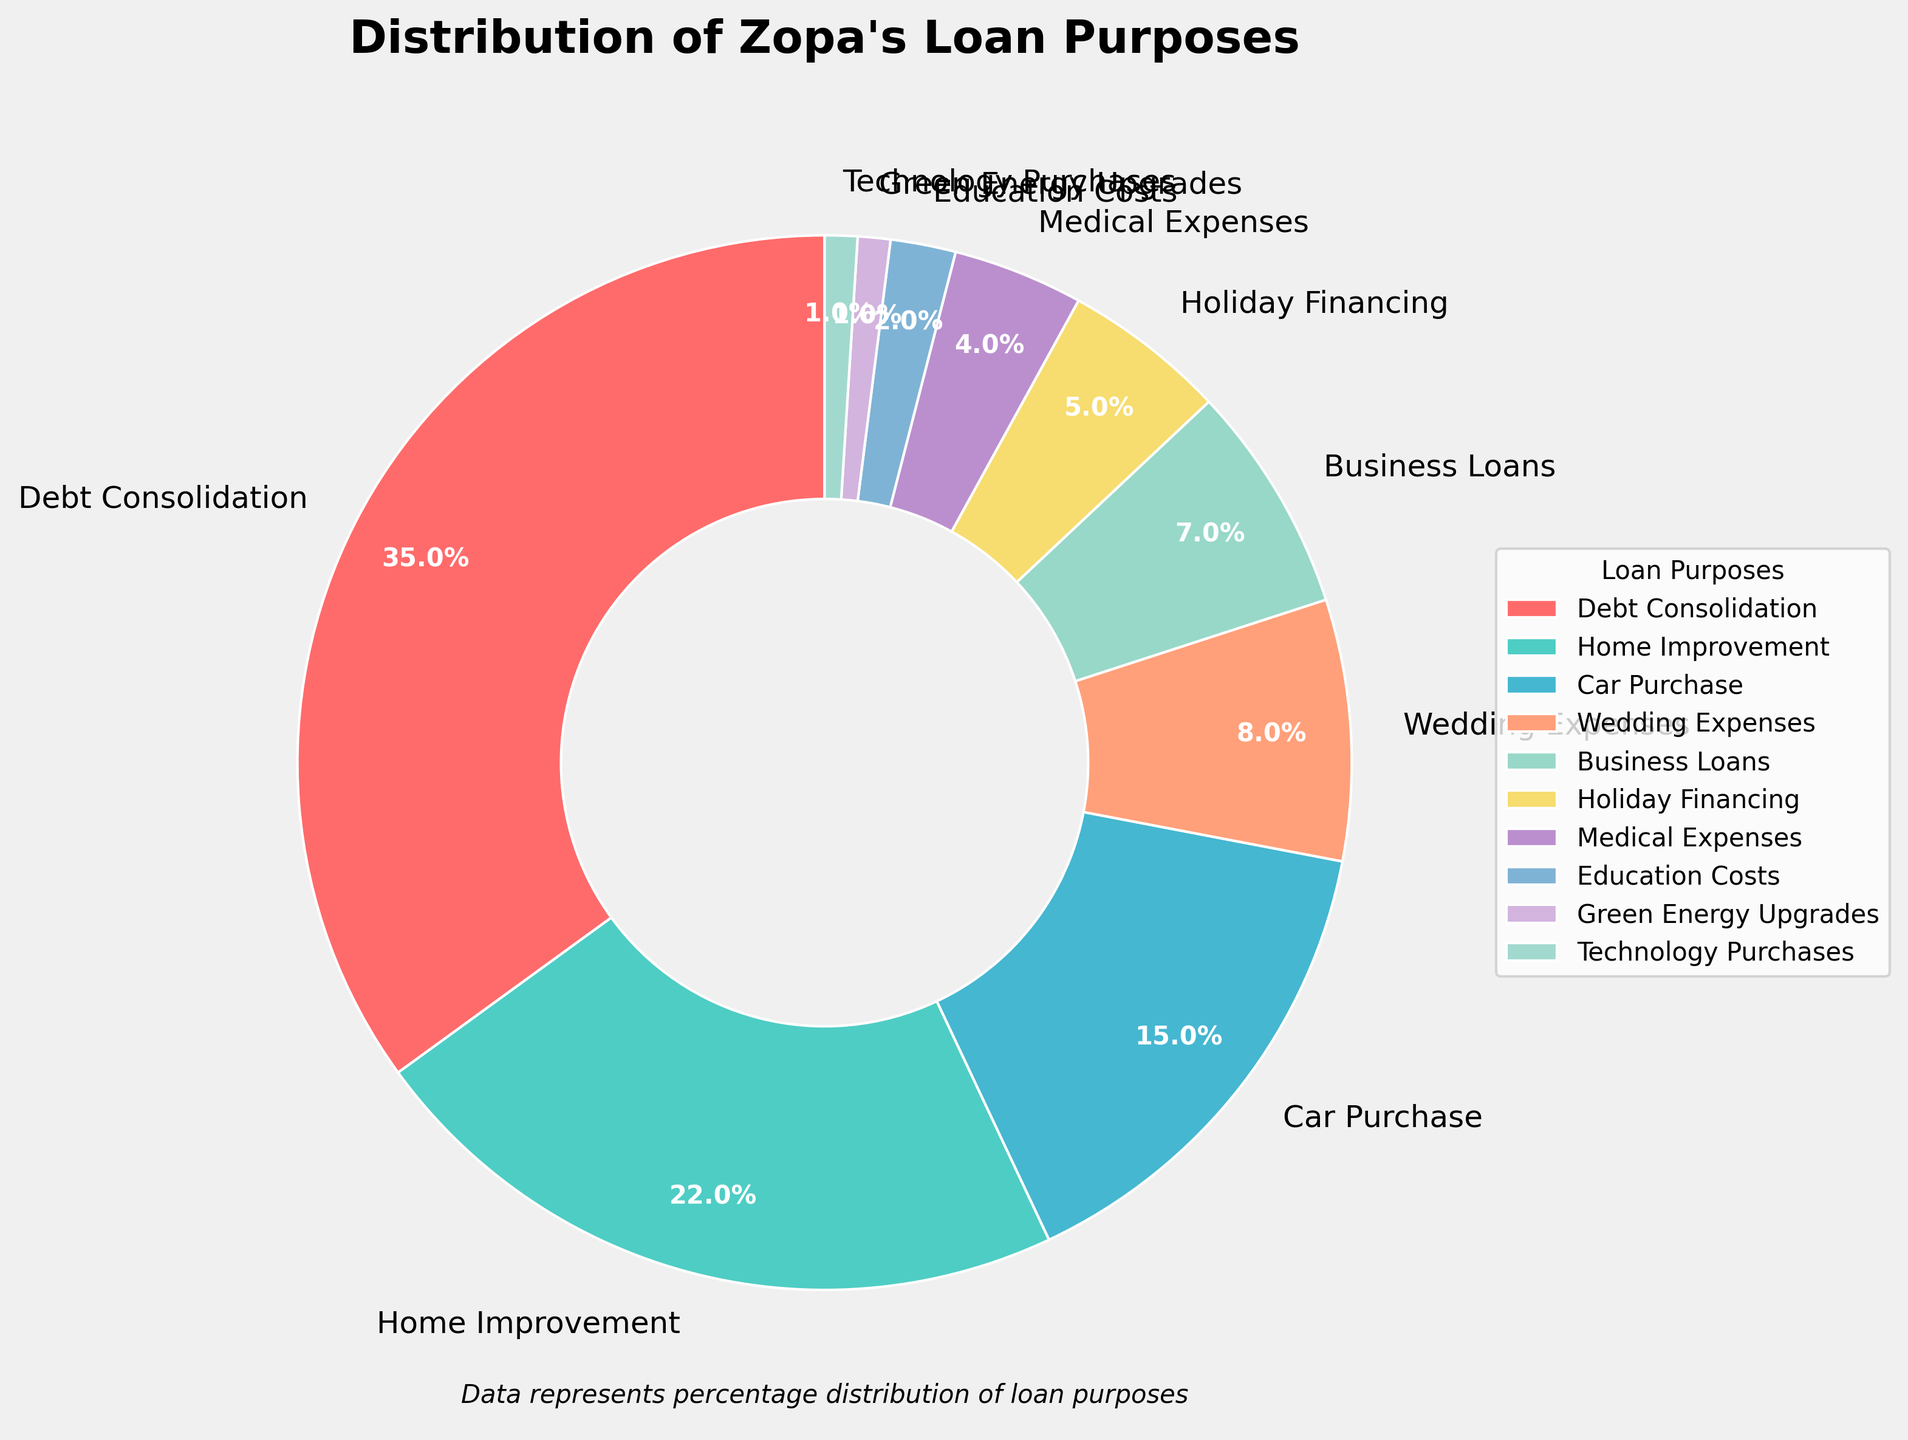What's the percentage of loans for Home Improvement? The label "Home Improvement" on the pie chart indicates the percentage directly. Refer to the figure to find the percentage associated with Home Improvement.
Answer: 22% Which loan purpose has the smallest percentage? Examine each segment of the pie chart and compare to identify the segment with the smallest percentage.
Answer: Technology Purchases Are Wedding Expenses greater than Business Loans in percentage? Examine the segments labeled "Wedding Expenses" and "Business Loans" and compare their percentages to determine which is greater.
Answer: Yes Which purpose occupies the largest segment of the pie chart? Look at the segments of the pie chart and identify the segment with the largest slice, indicated by its label and associated percentage.
Answer: Debt Consolidation Are there more loans for Business Loans or Medical Expenses? Compare the segments labeled "Business Loans" and "Medical Expenses" in the pie chart. Determine which segment represents a larger percentage.
Answer: Business Loans 